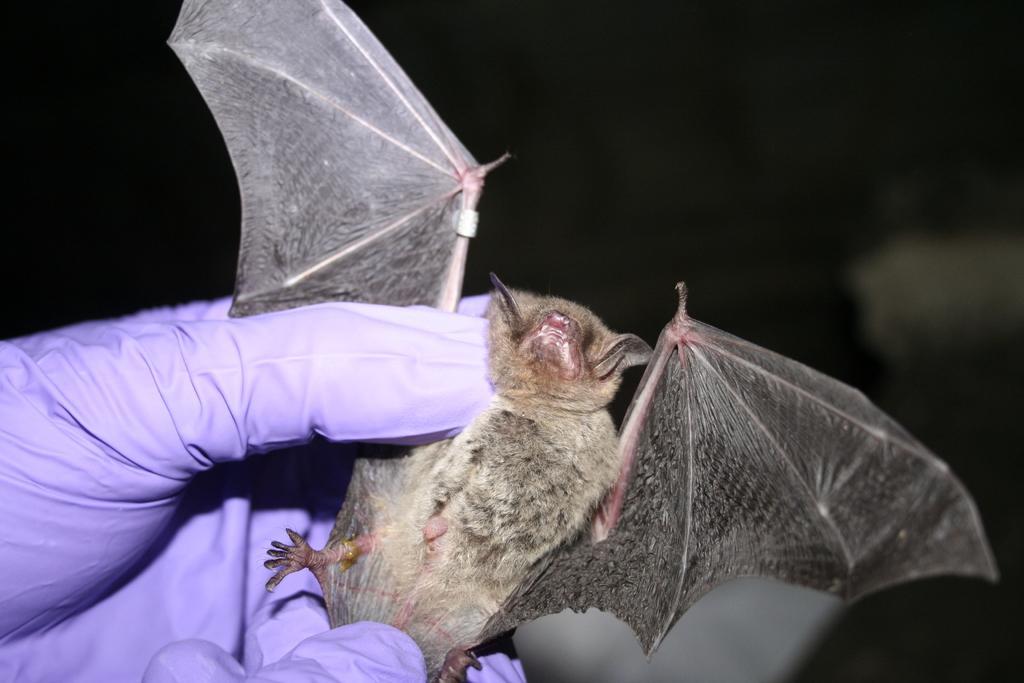Describe this image in one or two sentences. In this image, on the left corner, we can see a hand of a person which is covered with gloves and holding an animal with its wings. In the background, we can see black color. 